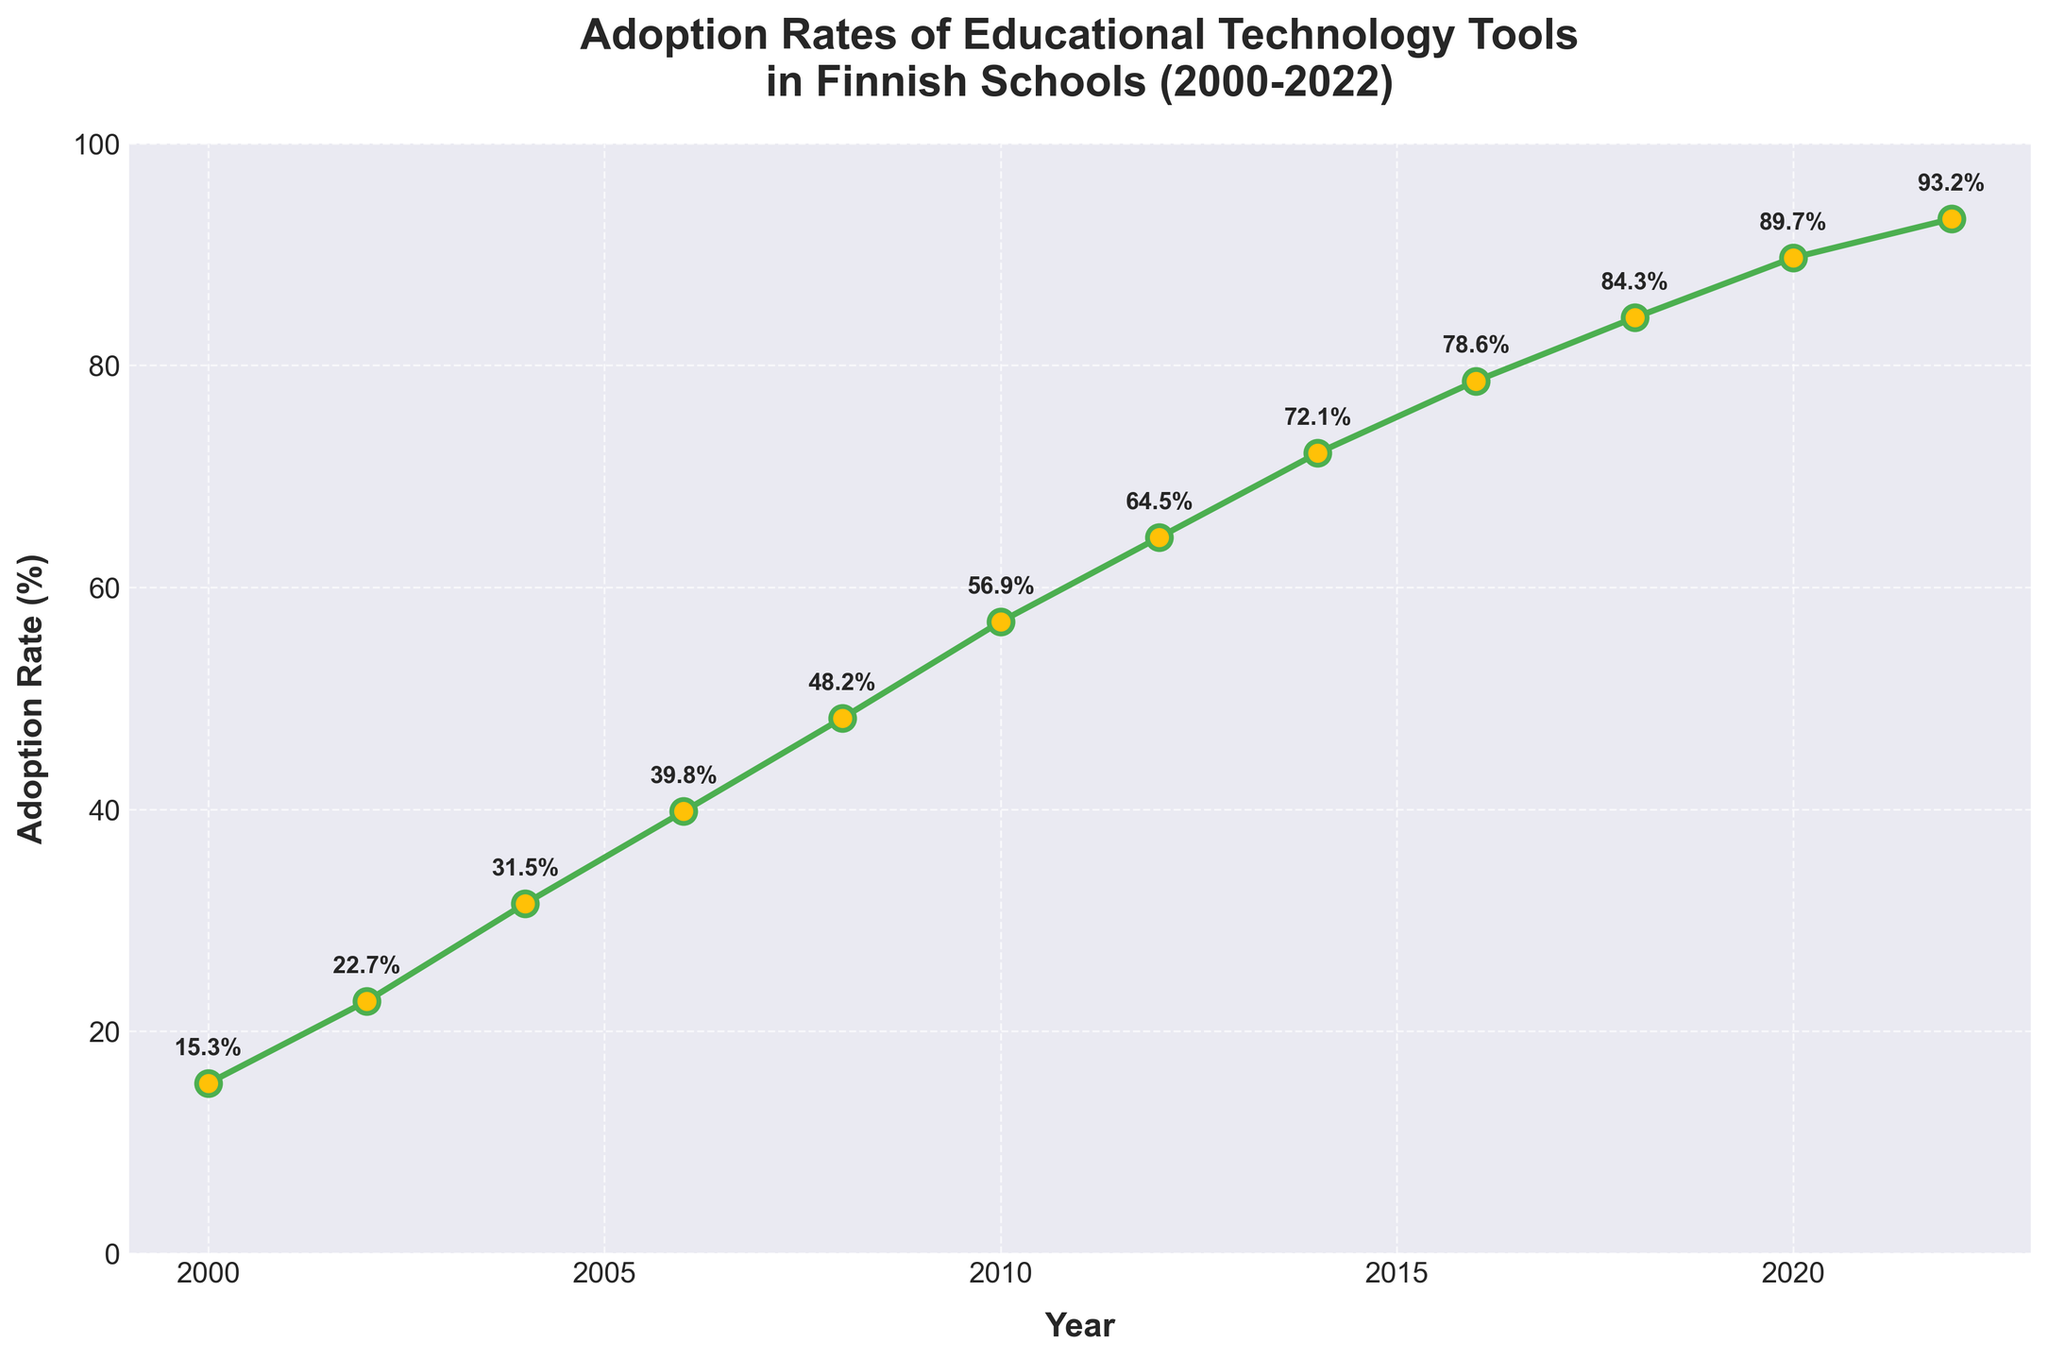What year marks the first time the adoption rate exceeded 50%? We need to look for the first year where the adoption rate crosses 50%. From the data, we see that the adoption rate is 56.9% in 2010, so 2010 is the year when the adoption rate first exceeded 50%.
Answer: 2010 Between which two consecutive years did the adoption rate increase the most? We need to find the largest difference between adoption rates of consecutive years. By calculating the differences: 
2002-2000 = 7.4%, 2004-2002 = 8.8%, 2006-2004 = 8.3%, 2008-2006 = 8.4%, 2010-2008 = 8.7%, 2012-2010 = 7.6%, 2014-2012 = 7.6%, 2016-2014 = 6.5%, 2018-2016 = 5.7%, 2020-2018 = 5.4%, and 2022-2020 = 3.5%. The largest increase is 8.8% between 2002 and 2004.
Answer: 2002 and 2004 What is the average adoption rate from 2000 to 2022? Sum all adoption rates from 2000 to 2022, then divide by the number of data points. The total sum is 15.3 + 22.7 + 31.5 + 39.8 + 48.2 + 56.9 + 64.5 + 72.1 + 78.6 + 84.3 + 89.7 + 93.2 = 697.8, and there are 12 data points, so the average is 697.8 / 12 ≈ 58.15%.
Answer: 58.15% How much did the adoption rate change from 2000 to 2022? Subtract the adoption rate in 2000 from the adoption rate in 2022. The adoption rate in 2022 is 93.2% and in 2000 is 15.3%, so the change is 93.2% - 15.3% = 77.9%.
Answer: 77.9% Which period had a higher average adoption rate: 2000-2010 or 2012-2022? Calculate the averages for both periods. 
For 2000-2010: (15.3 + 22.7 + 31.5 + 39.8 + 48.2 + 56.9) / 6 = 214.4 / 6 ≈ 35.73%. 
For 2012-2022: (64.5 + 72.1 + 78.6 + 84.3 + 89.7 + 93.2) / 6 = 482.4 / 6 ≈ 80.4%. 
The period 2012-2022 had a higher average adoption rate.
Answer: 2012-2022 What is the visual style of the line representing adoption rates in terms of color and line style? The line representing adoption rates is depicted with green color and has a continuous, solid line style. The markers are yellow circles with green edges.
Answer: Green with solid line style and yellow markers 